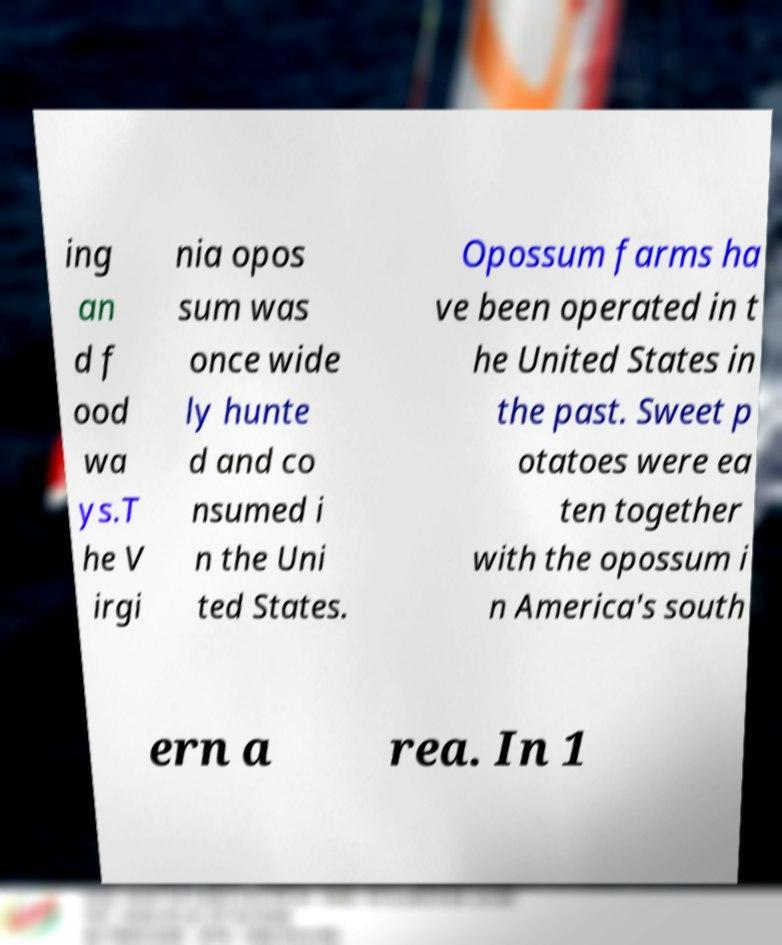There's text embedded in this image that I need extracted. Can you transcribe it verbatim? ing an d f ood wa ys.T he V irgi nia opos sum was once wide ly hunte d and co nsumed i n the Uni ted States. Opossum farms ha ve been operated in t he United States in the past. Sweet p otatoes were ea ten together with the opossum i n America's south ern a rea. In 1 